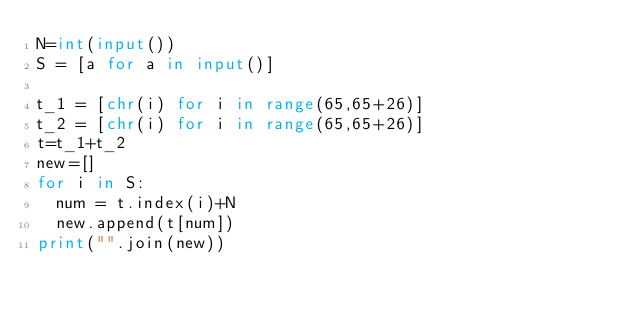Convert code to text. <code><loc_0><loc_0><loc_500><loc_500><_Python_>N=int(input())
S = [a for a in input()]

t_1 = [chr(i) for i in range(65,65+26)]
t_2 = [chr(i) for i in range(65,65+26)]
t=t_1+t_2
new=[]
for i in S:
  num = t.index(i)+N
  new.append(t[num])
print("".join(new))
</code> 